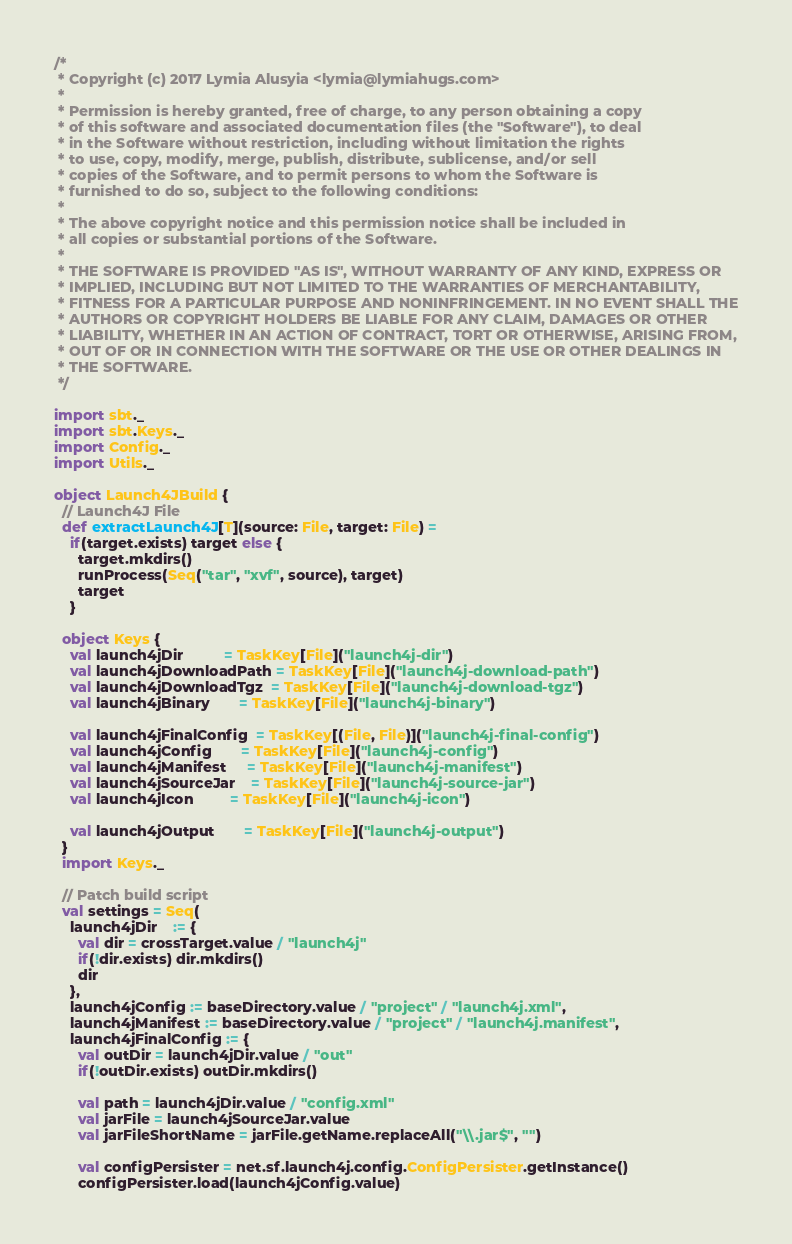Convert code to text. <code><loc_0><loc_0><loc_500><loc_500><_Scala_>/*
 * Copyright (c) 2017 Lymia Alusyia <lymia@lymiahugs.com>
 *
 * Permission is hereby granted, free of charge, to any person obtaining a copy
 * of this software and associated documentation files (the "Software"), to deal
 * in the Software without restriction, including without limitation the rights
 * to use, copy, modify, merge, publish, distribute, sublicense, and/or sell
 * copies of the Software, and to permit persons to whom the Software is
 * furnished to do so, subject to the following conditions:
 *
 * The above copyright notice and this permission notice shall be included in
 * all copies or substantial portions of the Software.
 *
 * THE SOFTWARE IS PROVIDED "AS IS", WITHOUT WARRANTY OF ANY KIND, EXPRESS OR
 * IMPLIED, INCLUDING BUT NOT LIMITED TO THE WARRANTIES OF MERCHANTABILITY,
 * FITNESS FOR A PARTICULAR PURPOSE AND NONINFRINGEMENT. IN NO EVENT SHALL THE
 * AUTHORS OR COPYRIGHT HOLDERS BE LIABLE FOR ANY CLAIM, DAMAGES OR OTHER
 * LIABILITY, WHETHER IN AN ACTION OF CONTRACT, TORT OR OTHERWISE, ARISING FROM,
 * OUT OF OR IN CONNECTION WITH THE SOFTWARE OR THE USE OR OTHER DEALINGS IN
 * THE SOFTWARE.
 */

import sbt._
import sbt.Keys._
import Config._
import Utils._

object Launch4JBuild {
  // Launch4J File
  def extractLaunch4J[T](source: File, target: File) =
    if(target.exists) target else {
      target.mkdirs()
      runProcess(Seq("tar", "xvf", source), target)
      target
    }

  object Keys {
    val launch4jDir          = TaskKey[File]("launch4j-dir")
    val launch4jDownloadPath = TaskKey[File]("launch4j-download-path")
    val launch4jDownloadTgz  = TaskKey[File]("launch4j-download-tgz")
    val launch4jBinary       = TaskKey[File]("launch4j-binary")

    val launch4jFinalConfig  = TaskKey[(File, File)]("launch4j-final-config")
    val launch4jConfig       = TaskKey[File]("launch4j-config")
    val launch4jManifest     = TaskKey[File]("launch4j-manifest")
    val launch4jSourceJar    = TaskKey[File]("launch4j-source-jar")
    val launch4jIcon         = TaskKey[File]("launch4j-icon")

    val launch4jOutput       = TaskKey[File]("launch4j-output")
  }
  import Keys._

  // Patch build script
  val settings = Seq(
    launch4jDir    := {
      val dir = crossTarget.value / "launch4j"
      if(!dir.exists) dir.mkdirs()
      dir
    },
    launch4jConfig := baseDirectory.value / "project" / "launch4j.xml",
    launch4jManifest := baseDirectory.value / "project" / "launch4j.manifest",
    launch4jFinalConfig := {
      val outDir = launch4jDir.value / "out"
      if(!outDir.exists) outDir.mkdirs()

      val path = launch4jDir.value / "config.xml"
      val jarFile = launch4jSourceJar.value
      val jarFileShortName = jarFile.getName.replaceAll("\\.jar$", "")

      val configPersister = net.sf.launch4j.config.ConfigPersister.getInstance()
      configPersister.load(launch4jConfig.value)</code> 